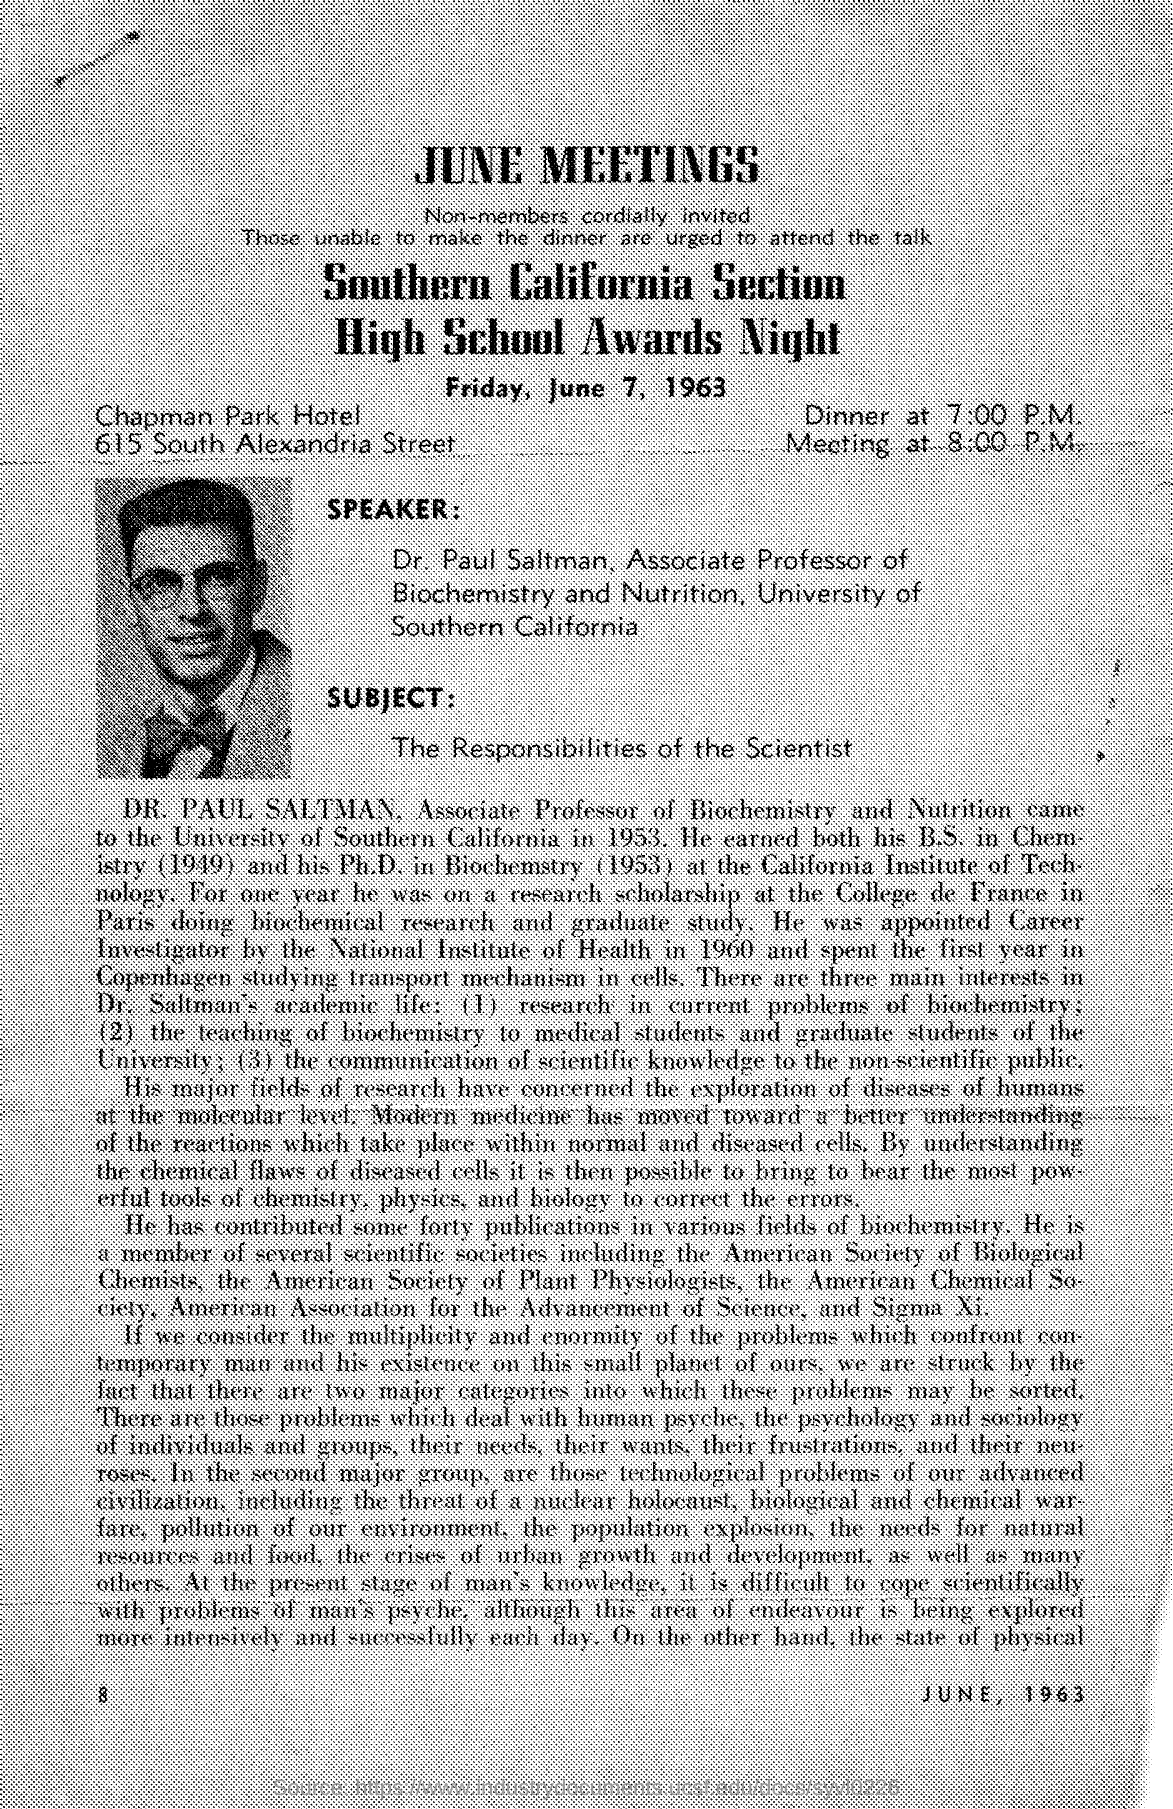What is the date scheduled for high school awards as mentioned in the given form ?
Your answer should be compact. FRIDAY, JUNE 7, 1963. What is the time of dinner mentioned in the given form ?
Offer a terse response. 7:00 P.M. At what time meeting is scheduled ?
Your answer should be very brief. 8:00 P.M. What is the name of the hotel mentioned in the given page ?
Make the answer very short. Chapman park hotel. What is the name of the speaker mentioned in the given page ?
Offer a very short reply. DR. PAUL SALTMAN. To which university dr.paul saltman belongs to ?
Your answer should be compact. University of southern california. 